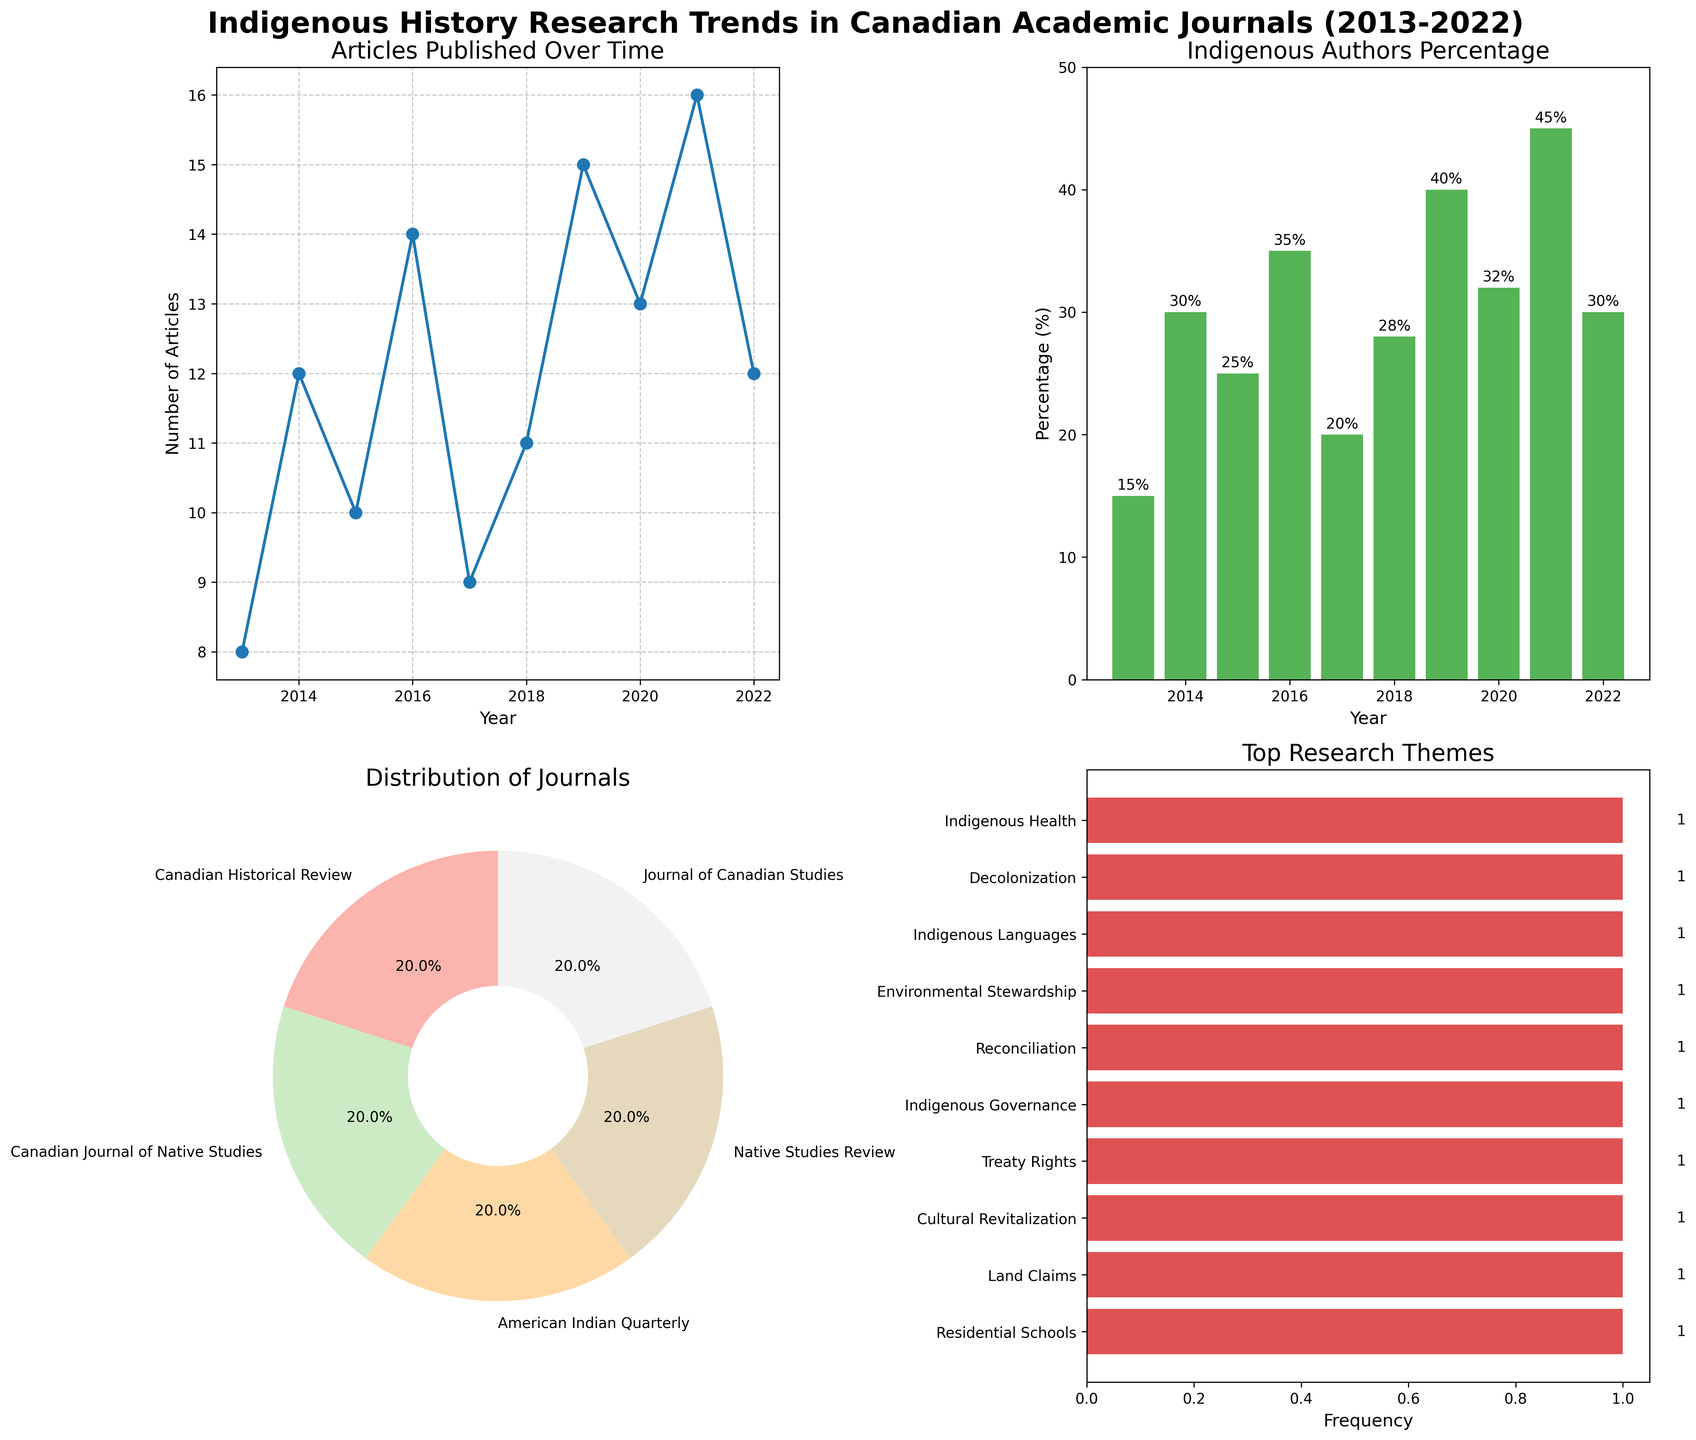What is the highest percentage of Indigenous authors in any given year? To find the highest percentage, look at the bar heights in the "Indigenous Authors Percentage" bar chart. The tallest bar is for the year 2021, which reaches up to 45%.
Answer: 45% Which journal published the most articles in a single year? Review the "Articles Published Over Time" line plot for the highest peak. The highest value is 16 articles in 2021 by the journal "Native Studies Review".
Answer: Native Studies Review What was the most common research theme from 2013 to 2022? Check the "Top Research Themes" horizontal bar chart. The theme with the longest bar is "Reconciliation" with the highest frequency.
Answer: Reconciliation In which year did the "Canadian Historical Review" publish the least articles? Look at the "Articles Published Over Time" and filter out data points for "Canadian Historical Review". The year with the lowest value (8 articles) for this journal is 2013.
Answer: 2013 How many years had the "Canadian Journal of Native Studies" as the top research theme? Refer to the "Distribution of Journals" pie chart, where slices represent the counts of years each journal was the top theme. Count the segments labeled "Canadian Journal of Native Studies". The answer is 2 years (2014 and 2019).
Answer: 2 years What is the average number of articles published per year from 2013 to 2022 across all journals? Sum all the data points from the "Articles Published Over Time" plot: 8+12+10+14+9+11+15+13+16+12 = 120. Then, divide by the number of years: 120/10 = 12.
Answer: 12 Does the percentage of Indigenous authors correlate with the total number of articles published? To assess correlation visually, compare the "Articles Published Over Time" line plot with the "Indigenous Authors Percentage" bar plot. There is no clear visual correlation; peaks and valleys do not match.
Answer: No Which year had the highest focus on "Environmental Stewardship"? Look at the year labels in the "Top Research Themes" horizontal bar chart. The year with "Environmental Stewardship" as a top theme is 2019.
Answer: 2019 What is the total frequency of the theme "Residential Schools"? Summarize the count of "Residential Schools" in the "Top Research Themes" horizontal bar chart. There's only one occurrence.
Answer: 1 In which year was "Decolonization" the top research theme? The "Top Research Themes" horizontal bar identifies the specific theme by year. The year associated with "Decolonization" is 2021.
Answer: 2021 